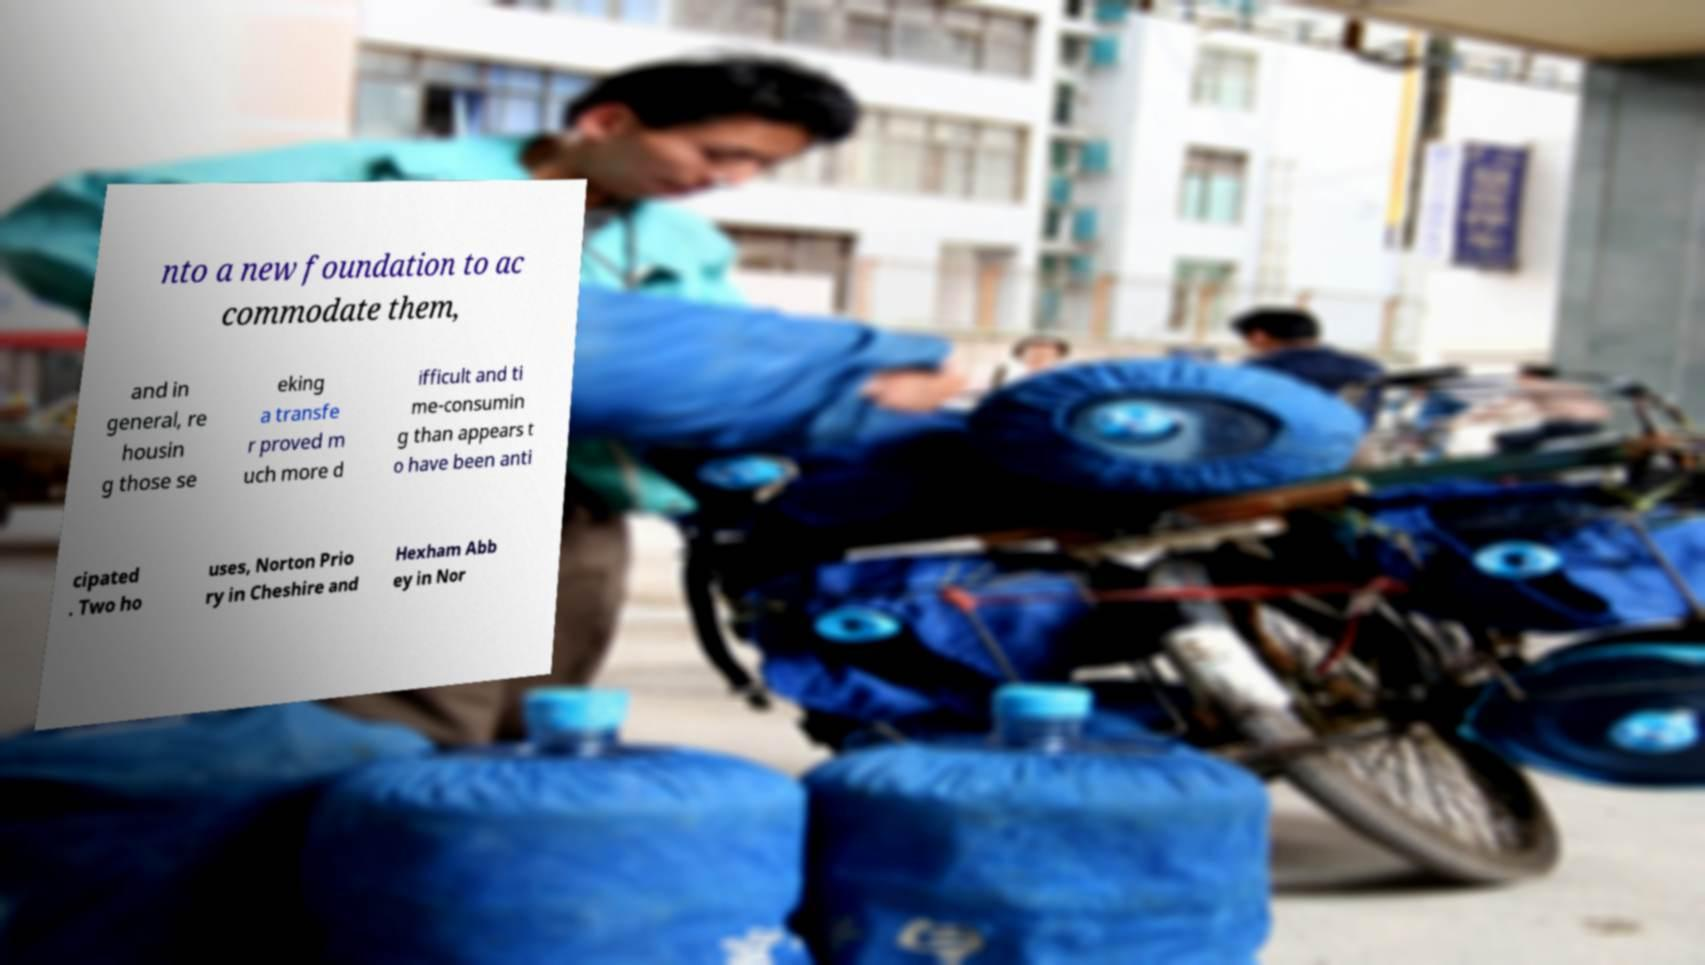Please identify and transcribe the text found in this image. nto a new foundation to ac commodate them, and in general, re housin g those se eking a transfe r proved m uch more d ifficult and ti me-consumin g than appears t o have been anti cipated . Two ho uses, Norton Prio ry in Cheshire and Hexham Abb ey in Nor 